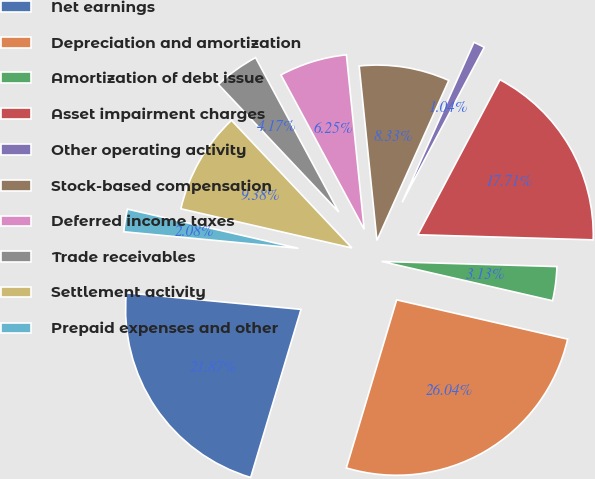Convert chart to OTSL. <chart><loc_0><loc_0><loc_500><loc_500><pie_chart><fcel>Net earnings<fcel>Depreciation and amortization<fcel>Amortization of debt issue<fcel>Asset impairment charges<fcel>Other operating activity<fcel>Stock-based compensation<fcel>Deferred income taxes<fcel>Trade receivables<fcel>Settlement activity<fcel>Prepaid expenses and other<nl><fcel>21.87%<fcel>26.04%<fcel>3.13%<fcel>17.71%<fcel>1.04%<fcel>8.33%<fcel>6.25%<fcel>4.17%<fcel>9.38%<fcel>2.08%<nl></chart> 